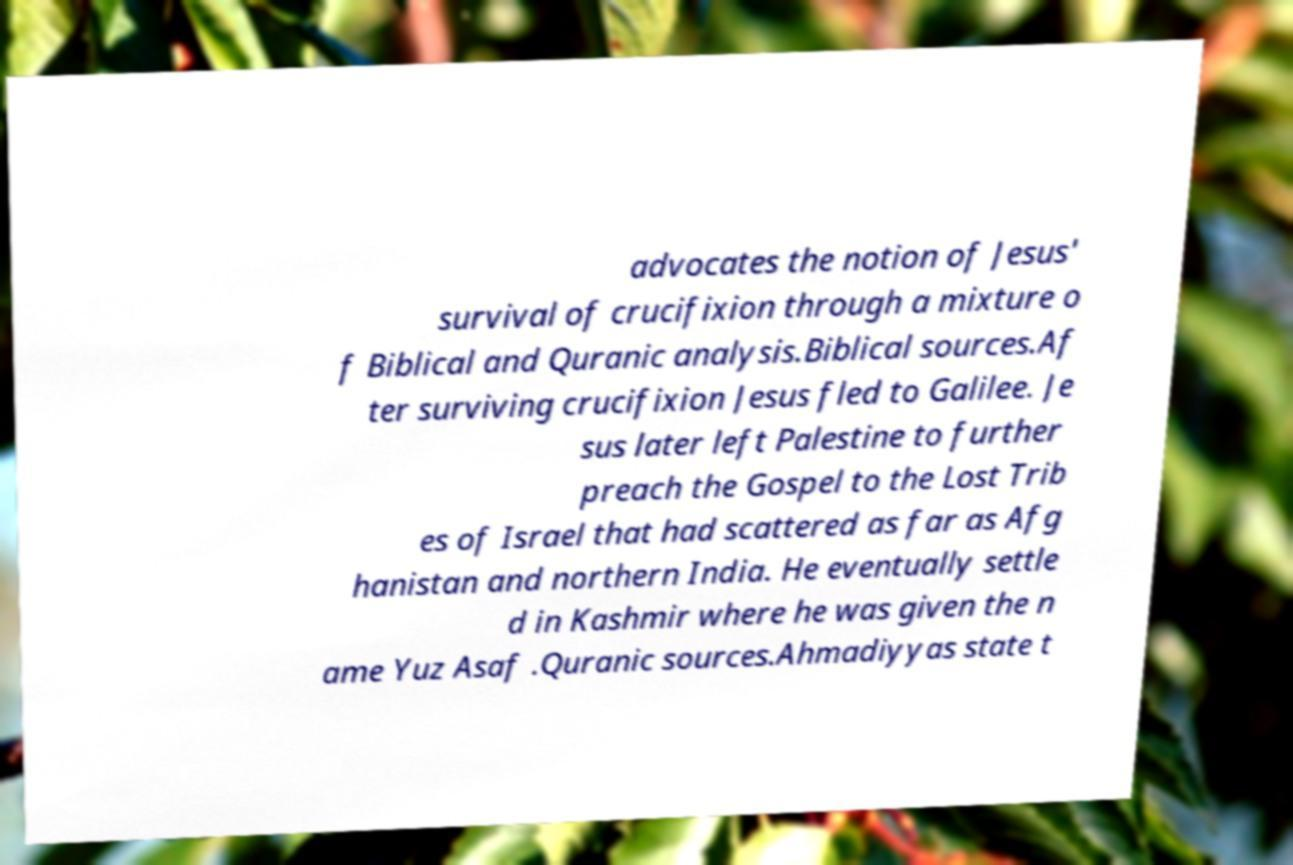Can you read and provide the text displayed in the image?This photo seems to have some interesting text. Can you extract and type it out for me? advocates the notion of Jesus' survival of crucifixion through a mixture o f Biblical and Quranic analysis.Biblical sources.Af ter surviving crucifixion Jesus fled to Galilee. Je sus later left Palestine to further preach the Gospel to the Lost Trib es of Israel that had scattered as far as Afg hanistan and northern India. He eventually settle d in Kashmir where he was given the n ame Yuz Asaf .Quranic sources.Ahmadiyyas state t 